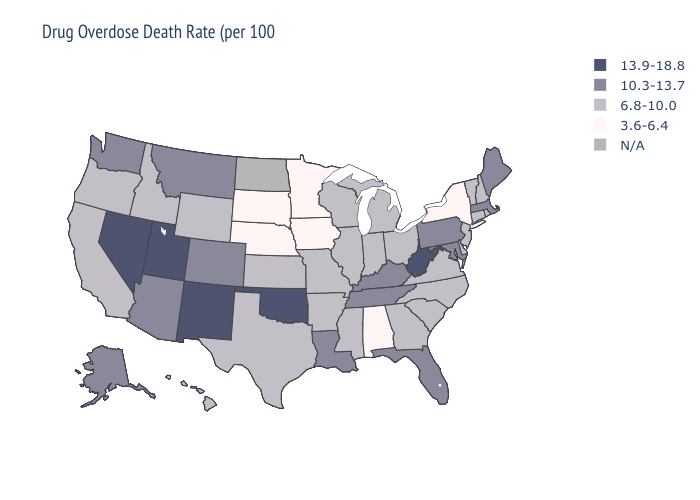What is the highest value in states that border Florida?
Quick response, please. 6.8-10.0. Does the map have missing data?
Keep it brief. Yes. Name the states that have a value in the range 13.9-18.8?
Quick response, please. Nevada, New Mexico, Oklahoma, Utah, West Virginia. Name the states that have a value in the range 6.8-10.0?
Answer briefly. Arkansas, California, Connecticut, Delaware, Georgia, Hawaii, Idaho, Illinois, Indiana, Kansas, Michigan, Mississippi, Missouri, New Hampshire, New Jersey, North Carolina, Ohio, Oregon, Rhode Island, South Carolina, Texas, Vermont, Virginia, Wisconsin, Wyoming. Does the map have missing data?
Keep it brief. Yes. Name the states that have a value in the range 6.8-10.0?
Keep it brief. Arkansas, California, Connecticut, Delaware, Georgia, Hawaii, Idaho, Illinois, Indiana, Kansas, Michigan, Mississippi, Missouri, New Hampshire, New Jersey, North Carolina, Ohio, Oregon, Rhode Island, South Carolina, Texas, Vermont, Virginia, Wisconsin, Wyoming. Among the states that border Ohio , does Michigan have the lowest value?
Concise answer only. Yes. What is the lowest value in the USA?
Answer briefly. 3.6-6.4. Does the first symbol in the legend represent the smallest category?
Be succinct. No. Does Indiana have the lowest value in the MidWest?
Short answer required. No. Among the states that border Illinois , which have the lowest value?
Quick response, please. Iowa. What is the value of Oklahoma?
Quick response, please. 13.9-18.8. What is the value of South Dakota?
Write a very short answer. 3.6-6.4. Which states have the highest value in the USA?
Quick response, please. Nevada, New Mexico, Oklahoma, Utah, West Virginia. 